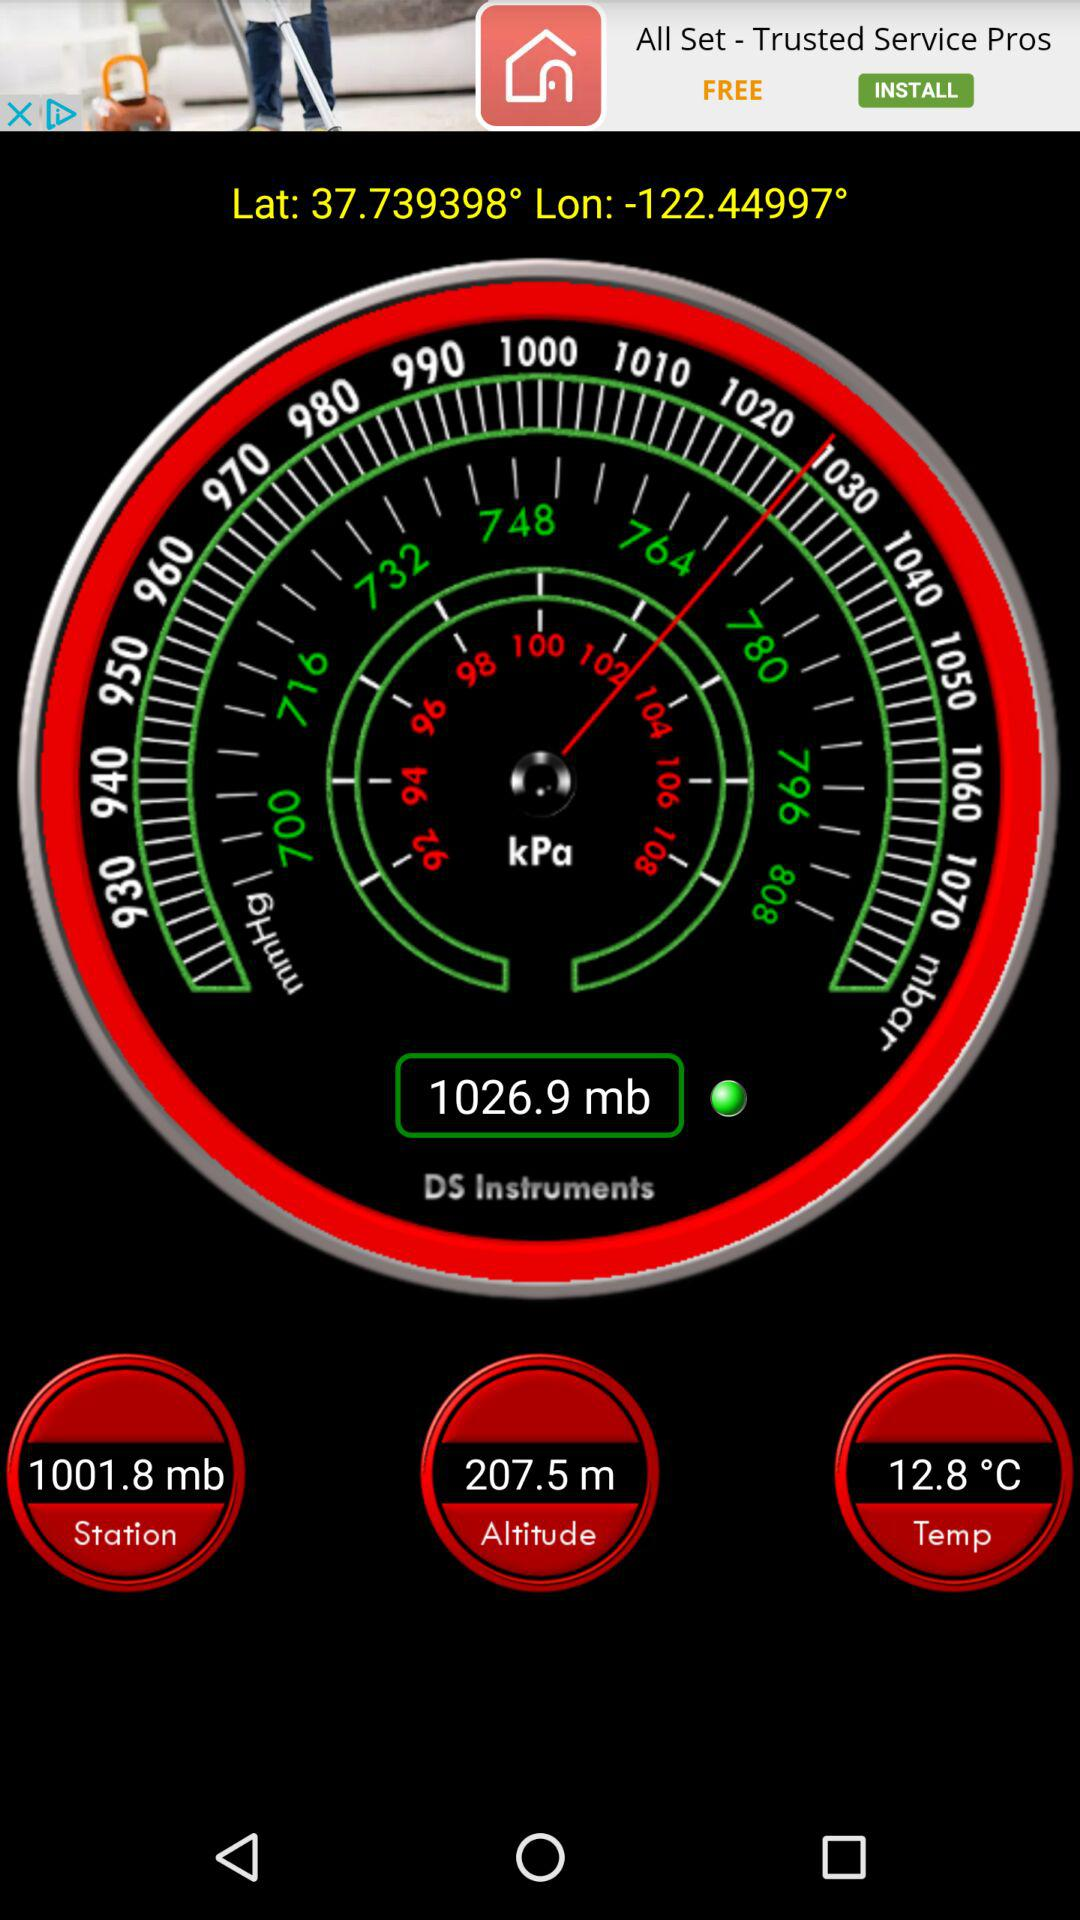What is the given altitude? The given altitude is 207.5 m. 